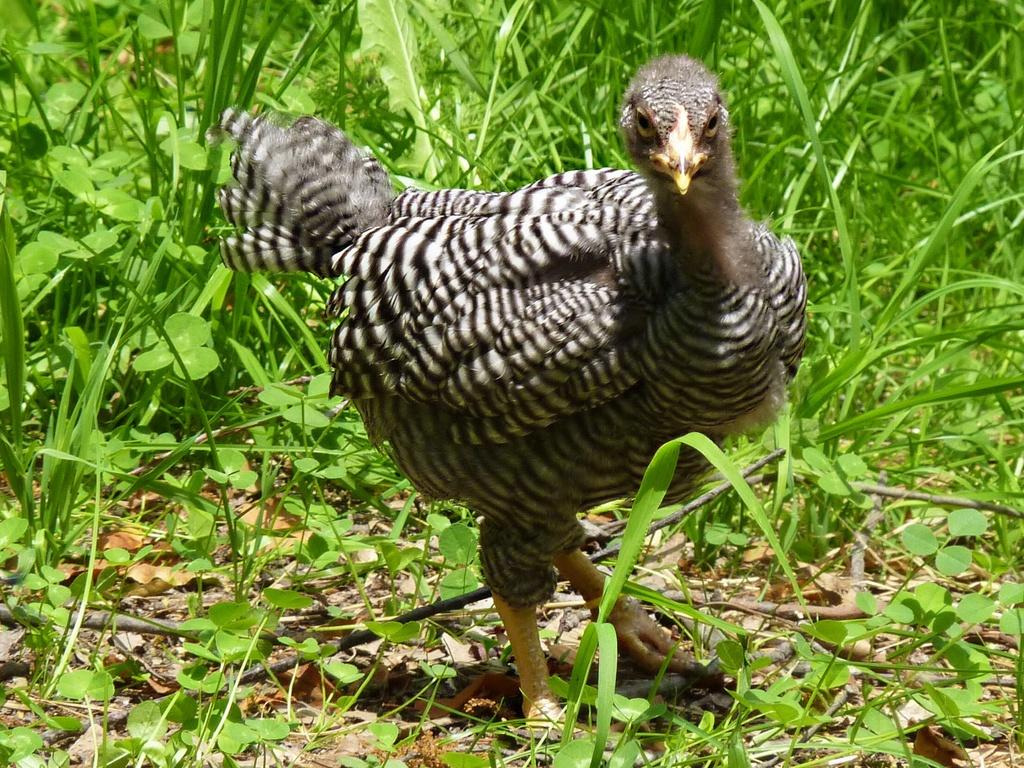What is the main subject of the image? There is a hen in the center of the image. Can you describe the appearance of the hen? The hen is black and white in color. What type of environment is visible in the background of the image? There is grass visible in the background of the image. What type of bait is the hen using to catch fish in the image? There is no bait or fish present in the image; it features a hen and grass in the background. How many rooms are visible in the image? There are no rooms visible in the image; it features a hen and grass in the background. 